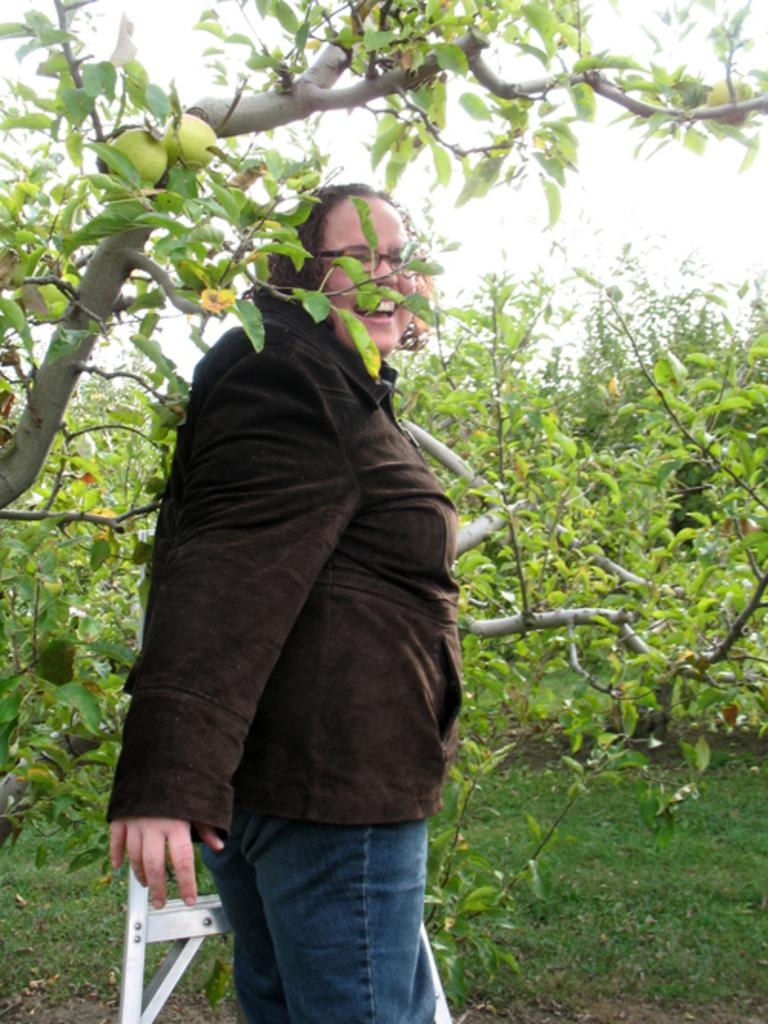What is the lady in the image doing? The lady is standing on a ladder. What type of vegetation can be seen in the image? There are many trees in the image. What is covering the ground in the image? There is grass on the ground. What can be seen in the background of the image? The sky is visible in the background. What type of grain is being harvested by the lady in the image? There is no grain present in the image, and the lady is not shown harvesting anything. 